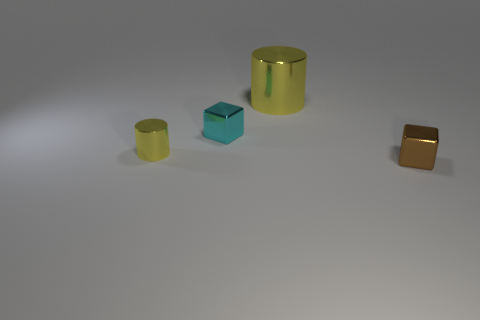There is a block that is to the left of the brown block; is it the same size as the large metallic object?
Give a very brief answer. No. Is there a yellow metal thing that has the same size as the cyan cube?
Ensure brevity in your answer.  Yes. There is a block that is in front of the small yellow cylinder; what is its color?
Make the answer very short. Brown. What shape is the tiny object that is in front of the cyan block and left of the large shiny cylinder?
Make the answer very short. Cylinder. What number of small yellow things have the same shape as the tiny brown metallic object?
Keep it short and to the point. 0. How many cylinders are there?
Your answer should be very brief. 2. There is a thing that is behind the tiny yellow metallic cylinder and in front of the big yellow cylinder; how big is it?
Your answer should be compact. Small. There is a brown shiny thing that is the same size as the cyan thing; what shape is it?
Offer a terse response. Cube. There is a yellow cylinder behind the cyan object; is there a big yellow cylinder right of it?
Provide a short and direct response. No. There is another small metal object that is the same shape as the tiny brown thing; what color is it?
Make the answer very short. Cyan. 